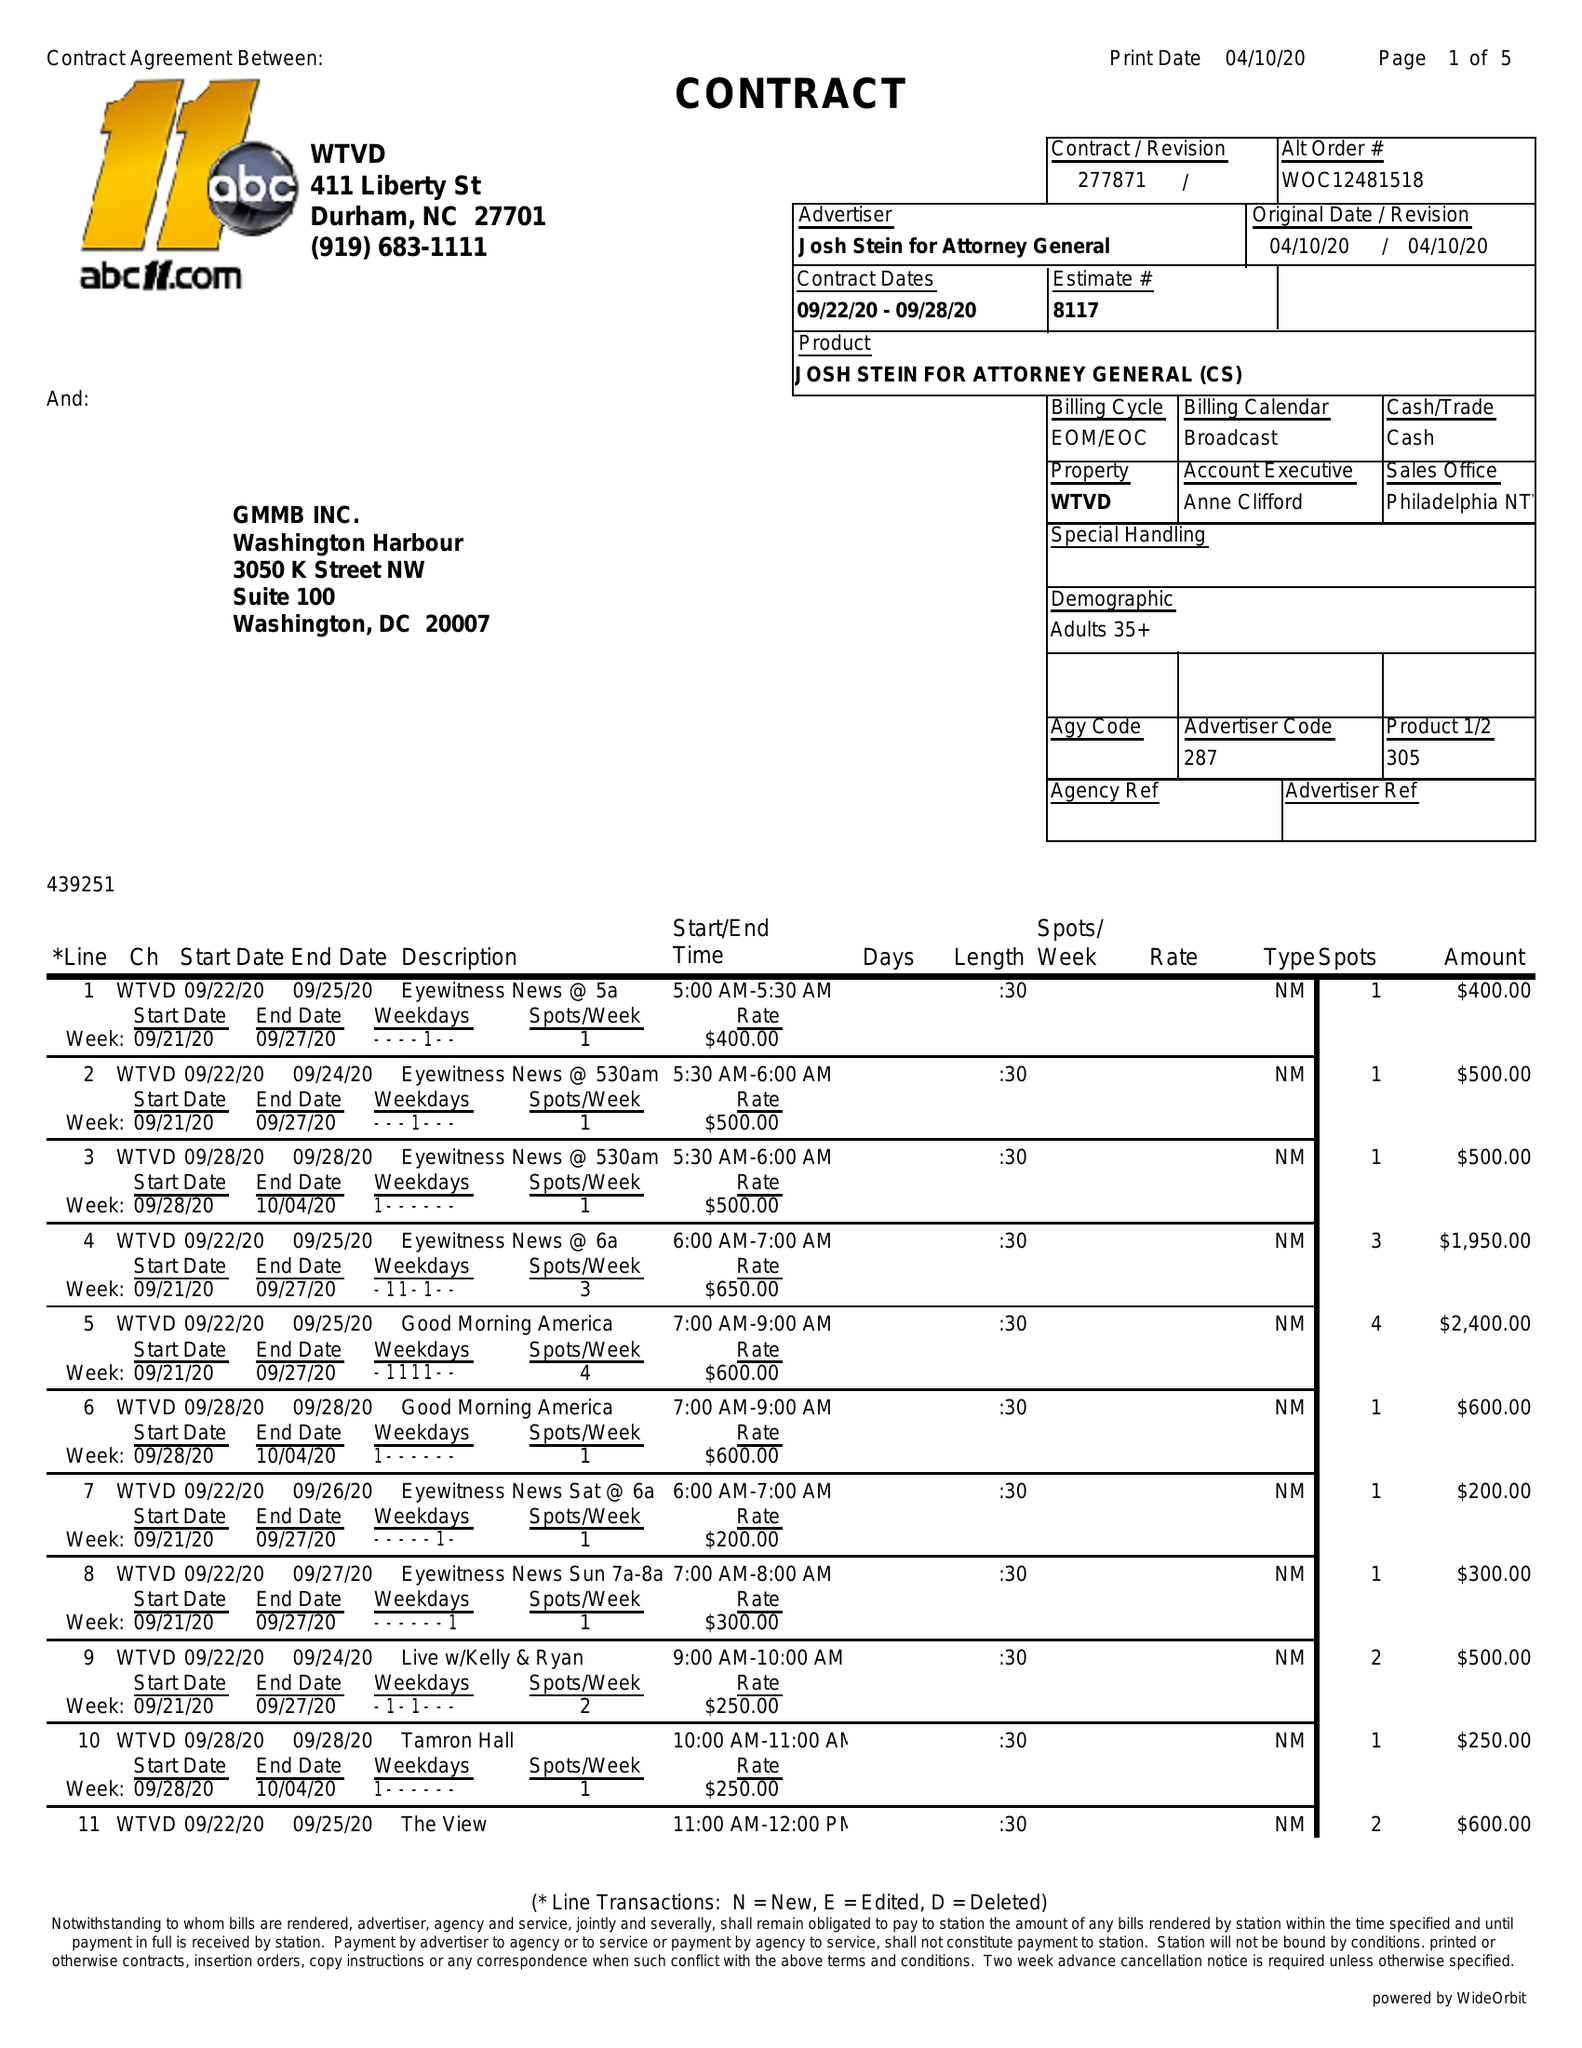What is the value for the gross_amount?
Answer the question using a single word or phrase. 33925.00 